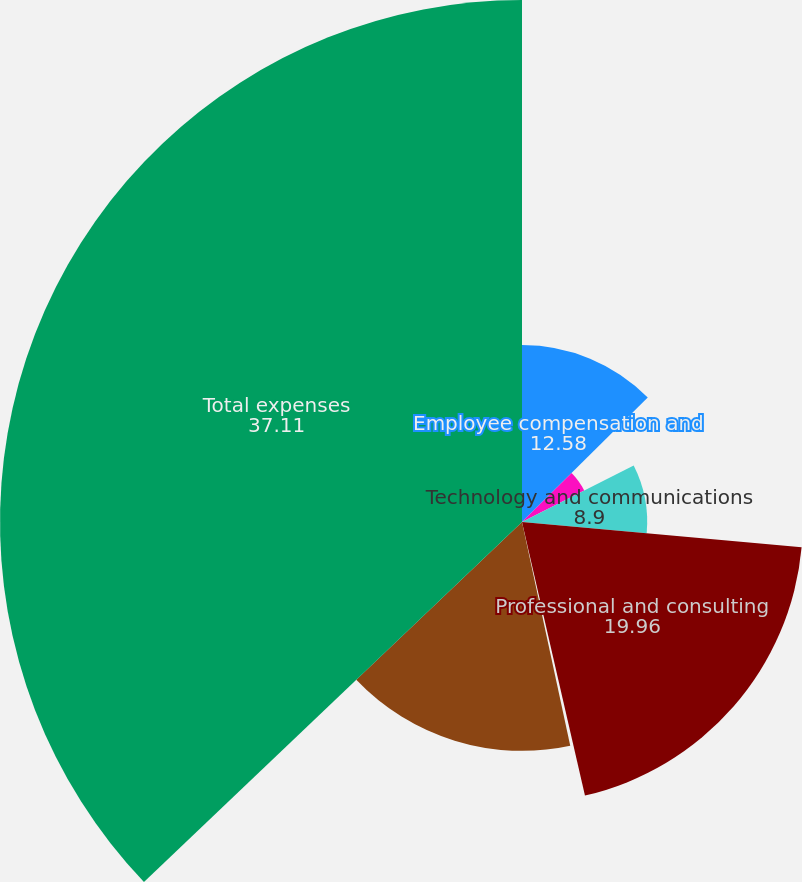Convert chart. <chart><loc_0><loc_0><loc_500><loc_500><pie_chart><fcel>Employee compensation and<fcel>Depreciation and amortization<fcel>Technology and communications<fcel>Professional and consulting<fcel>Marketing and advertising<fcel>General and administrative<fcel>Total expenses<nl><fcel>12.58%<fcel>4.96%<fcel>8.9%<fcel>19.96%<fcel>0.22%<fcel>16.27%<fcel>37.11%<nl></chart> 